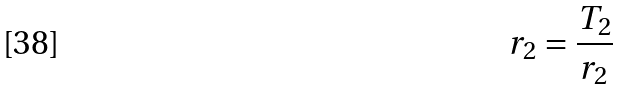<formula> <loc_0><loc_0><loc_500><loc_500>r _ { 2 } = \frac { T _ { 2 } } { r _ { 2 } }</formula> 